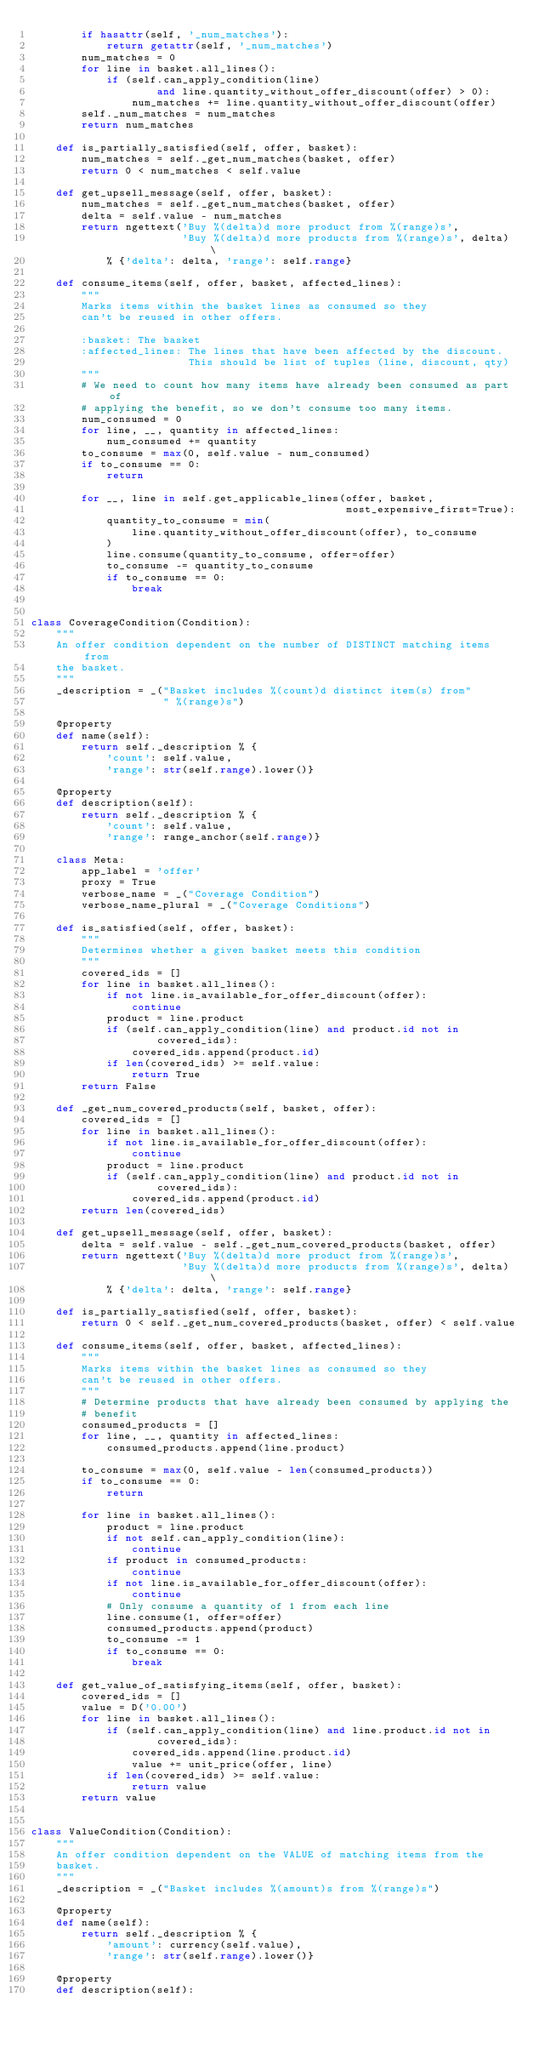<code> <loc_0><loc_0><loc_500><loc_500><_Python_>        if hasattr(self, '_num_matches'):
            return getattr(self, '_num_matches')
        num_matches = 0
        for line in basket.all_lines():
            if (self.can_apply_condition(line)
                    and line.quantity_without_offer_discount(offer) > 0):
                num_matches += line.quantity_without_offer_discount(offer)
        self._num_matches = num_matches
        return num_matches

    def is_partially_satisfied(self, offer, basket):
        num_matches = self._get_num_matches(basket, offer)
        return 0 < num_matches < self.value

    def get_upsell_message(self, offer, basket):
        num_matches = self._get_num_matches(basket, offer)
        delta = self.value - num_matches
        return ngettext('Buy %(delta)d more product from %(range)s',
                        'Buy %(delta)d more products from %(range)s', delta) \
            % {'delta': delta, 'range': self.range}

    def consume_items(self, offer, basket, affected_lines):
        """
        Marks items within the basket lines as consumed so they
        can't be reused in other offers.

        :basket: The basket
        :affected_lines: The lines that have been affected by the discount.
                         This should be list of tuples (line, discount, qty)
        """
        # We need to count how many items have already been consumed as part of
        # applying the benefit, so we don't consume too many items.
        num_consumed = 0
        for line, __, quantity in affected_lines:
            num_consumed += quantity
        to_consume = max(0, self.value - num_consumed)
        if to_consume == 0:
            return

        for __, line in self.get_applicable_lines(offer, basket,
                                                  most_expensive_first=True):
            quantity_to_consume = min(
                line.quantity_without_offer_discount(offer), to_consume
            )
            line.consume(quantity_to_consume, offer=offer)
            to_consume -= quantity_to_consume
            if to_consume == 0:
                break


class CoverageCondition(Condition):
    """
    An offer condition dependent on the number of DISTINCT matching items from
    the basket.
    """
    _description = _("Basket includes %(count)d distinct item(s) from"
                     " %(range)s")

    @property
    def name(self):
        return self._description % {
            'count': self.value,
            'range': str(self.range).lower()}

    @property
    def description(self):
        return self._description % {
            'count': self.value,
            'range': range_anchor(self.range)}

    class Meta:
        app_label = 'offer'
        proxy = True
        verbose_name = _("Coverage Condition")
        verbose_name_plural = _("Coverage Conditions")

    def is_satisfied(self, offer, basket):
        """
        Determines whether a given basket meets this condition
        """
        covered_ids = []
        for line in basket.all_lines():
            if not line.is_available_for_offer_discount(offer):
                continue
            product = line.product
            if (self.can_apply_condition(line) and product.id not in
                    covered_ids):
                covered_ids.append(product.id)
            if len(covered_ids) >= self.value:
                return True
        return False

    def _get_num_covered_products(self, basket, offer):
        covered_ids = []
        for line in basket.all_lines():
            if not line.is_available_for_offer_discount(offer):
                continue
            product = line.product
            if (self.can_apply_condition(line) and product.id not in
                    covered_ids):
                covered_ids.append(product.id)
        return len(covered_ids)

    def get_upsell_message(self, offer, basket):
        delta = self.value - self._get_num_covered_products(basket, offer)
        return ngettext('Buy %(delta)d more product from %(range)s',
                        'Buy %(delta)d more products from %(range)s', delta) \
            % {'delta': delta, 'range': self.range}

    def is_partially_satisfied(self, offer, basket):
        return 0 < self._get_num_covered_products(basket, offer) < self.value

    def consume_items(self, offer, basket, affected_lines):
        """
        Marks items within the basket lines as consumed so they
        can't be reused in other offers.
        """
        # Determine products that have already been consumed by applying the
        # benefit
        consumed_products = []
        for line, __, quantity in affected_lines:
            consumed_products.append(line.product)

        to_consume = max(0, self.value - len(consumed_products))
        if to_consume == 0:
            return

        for line in basket.all_lines():
            product = line.product
            if not self.can_apply_condition(line):
                continue
            if product in consumed_products:
                continue
            if not line.is_available_for_offer_discount(offer):
                continue
            # Only consume a quantity of 1 from each line
            line.consume(1, offer=offer)
            consumed_products.append(product)
            to_consume -= 1
            if to_consume == 0:
                break

    def get_value_of_satisfying_items(self, offer, basket):
        covered_ids = []
        value = D('0.00')
        for line in basket.all_lines():
            if (self.can_apply_condition(line) and line.product.id not in
                    covered_ids):
                covered_ids.append(line.product.id)
                value += unit_price(offer, line)
            if len(covered_ids) >= self.value:
                return value
        return value


class ValueCondition(Condition):
    """
    An offer condition dependent on the VALUE of matching items from the
    basket.
    """
    _description = _("Basket includes %(amount)s from %(range)s")

    @property
    def name(self):
        return self._description % {
            'amount': currency(self.value),
            'range': str(self.range).lower()}

    @property
    def description(self):</code> 